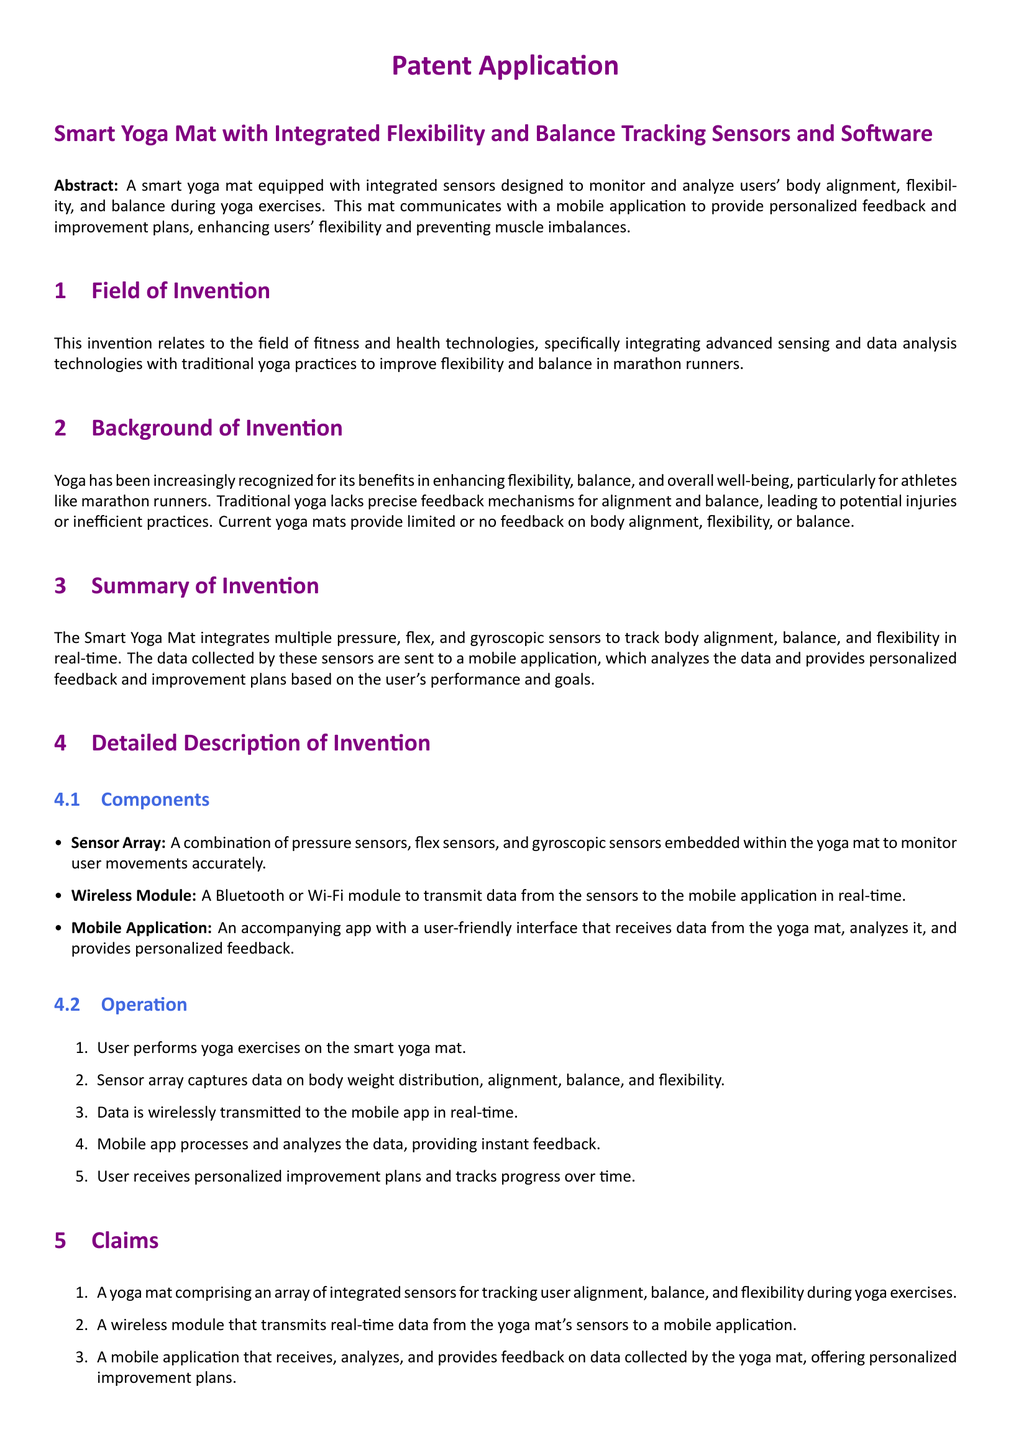What is the title of the patent application? The title is prominently stated at the beginning of the document, which gives an overview of the invention.
Answer: Smart Yoga Mat with Integrated Flexibility and Balance Tracking Sensors and Software What technology does the smart yoga mat integrate with yoga practices? The document discusses the integration of sensing and data analysis technologies to traditional yoga practices.
Answer: Advanced sensing and data analysis technologies What are the main components of the smart yoga mat? The components include specific technologies that enable the main functions of the device, listed in the document.
Answer: Sensor Array, Wireless Module, Mobile Application How does the mobile application provide feedback? The mobile application processes and analyzes data received from the yoga mat to present feedback.
Answer: Analyzes data and provides personalized feedback What is the primary benefit for marathon runners using the smart yoga mat? This benefit is specifically mentioned in the benefits section addressing a target audience for the invention.
Answer: Preventing muscle imbalances and enhancing overall performance What type of sensors are embedded in the yoga mat? The document lists specific types of sensors that are used to monitor user movements accurately.
Answer: Pressure, flex, and gyroscopic sensors Which communication method does the yoga mat use? The document specifies the technology that enables data transmission from the mat to the mobile app.
Answer: Bluetooth or Wi-Fi module How many claims are presented in the patent application? The document lists the claims that the invention asserts, which is a standard section in patent applications.
Answer: Three claims 